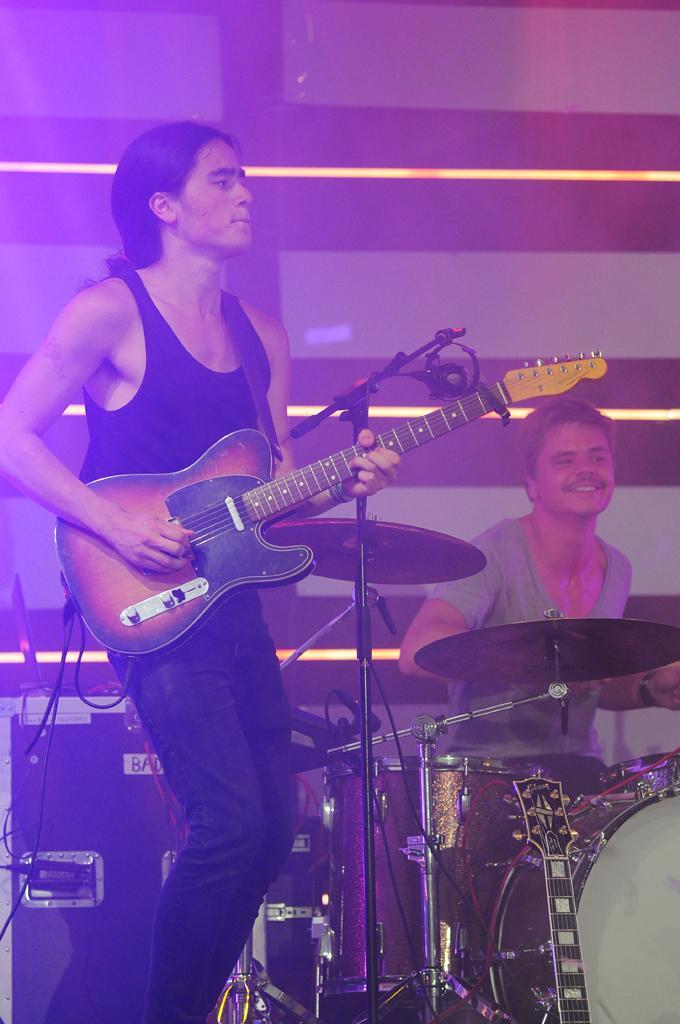Describe this image in one or two sentences. In this image there are two men playing musical instruments, in the background there is a wall. 